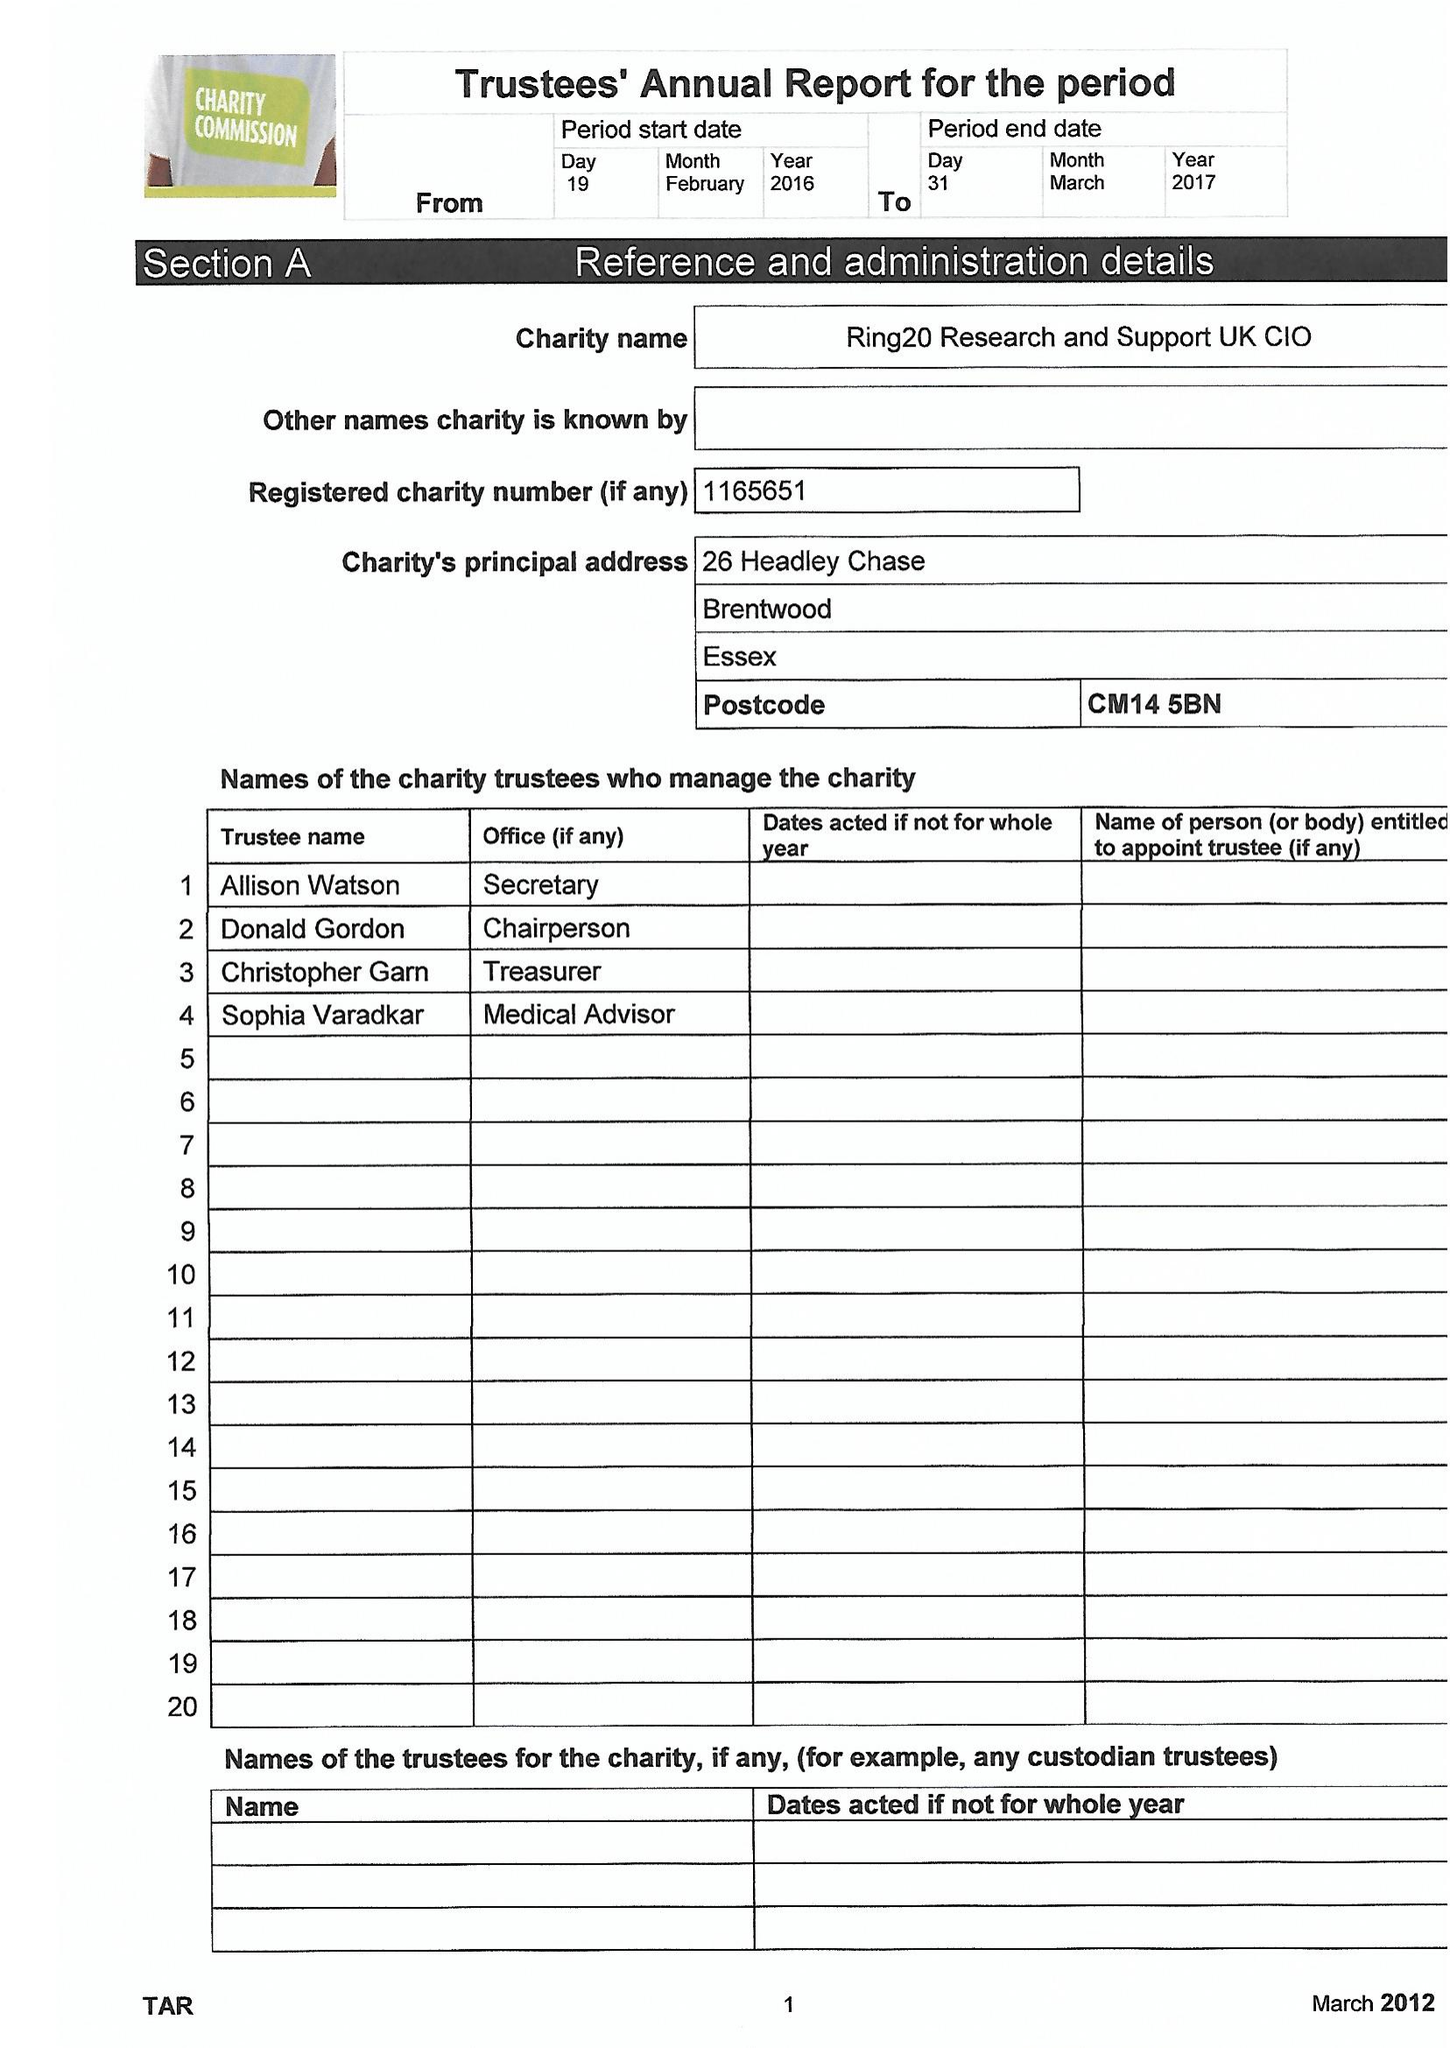What is the value for the spending_annually_in_british_pounds?
Answer the question using a single word or phrase. 8283.00 